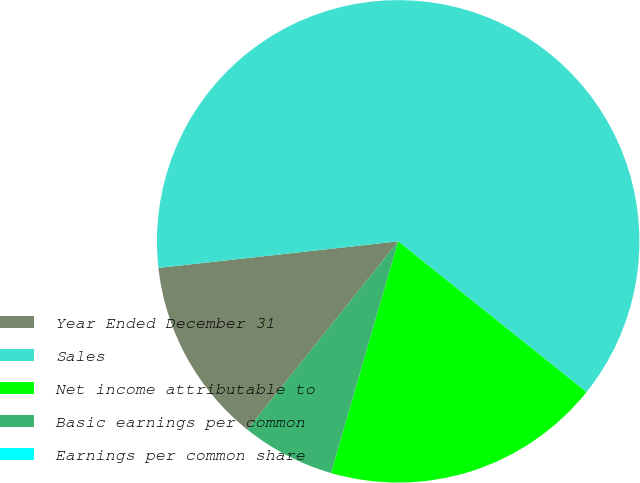Convert chart to OTSL. <chart><loc_0><loc_0><loc_500><loc_500><pie_chart><fcel>Year Ended December 31<fcel>Sales<fcel>Net income attributable to<fcel>Basic earnings per common<fcel>Earnings per common share<nl><fcel>12.5%<fcel>62.49%<fcel>18.75%<fcel>6.25%<fcel>0.0%<nl></chart> 